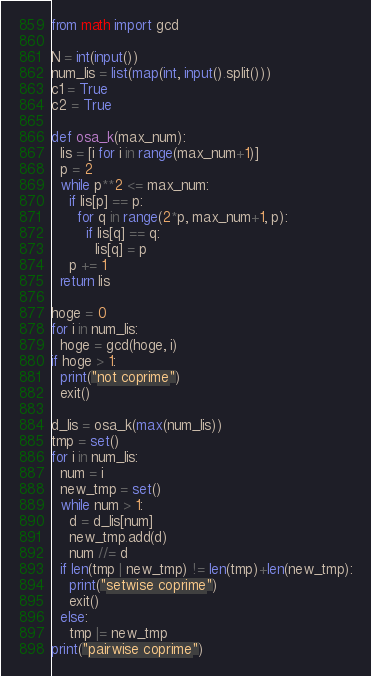Convert code to text. <code><loc_0><loc_0><loc_500><loc_500><_Python_>from math import gcd

N = int(input())
num_lis = list(map(int, input().split()))
c1 = True
c2 = True

def osa_k(max_num):
  lis = [i for i in range(max_num+1)]
  p = 2
  while p**2 <= max_num:
    if lis[p] == p:
      for q in range(2*p, max_num+1, p):
        if lis[q] == q:
          lis[q] = p
    p += 1
  return lis

hoge = 0
for i in num_lis:
  hoge = gcd(hoge, i)
if hoge > 1:
  print("not coprime")
  exit()

d_lis = osa_k(max(num_lis))
tmp = set()
for i in num_lis:
  num = i
  new_tmp = set()
  while num > 1:
    d = d_lis[num]
    new_tmp.add(d)
    num //= d
  if len(tmp | new_tmp) != len(tmp)+len(new_tmp):
    print("setwise coprime")
    exit()
  else:
    tmp |= new_tmp
print("pairwise coprime")
</code> 